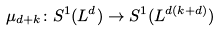<formula> <loc_0><loc_0><loc_500><loc_500>\mu _ { d + k } \colon S ^ { 1 } ( L ^ { d } ) \to S ^ { 1 } ( L ^ { d ( k + d ) } )</formula> 